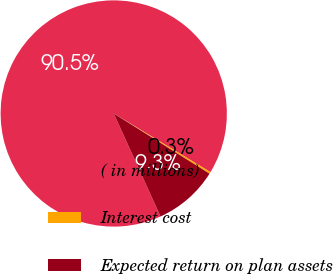Convert chart. <chart><loc_0><loc_0><loc_500><loc_500><pie_chart><fcel>( in millions)<fcel>Interest cost<fcel>Expected return on plan assets<nl><fcel>90.46%<fcel>0.26%<fcel>9.28%<nl></chart> 